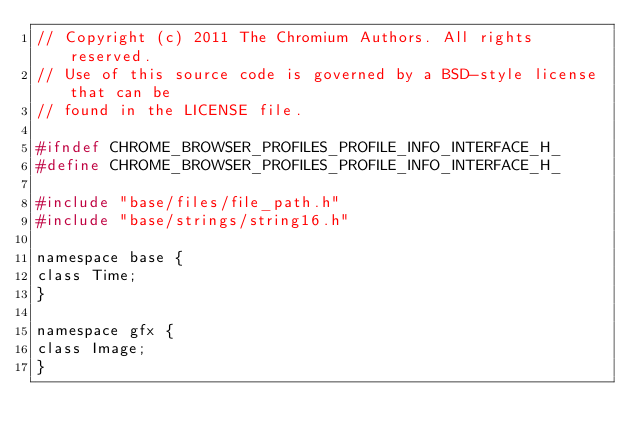Convert code to text. <code><loc_0><loc_0><loc_500><loc_500><_C_>// Copyright (c) 2011 The Chromium Authors. All rights reserved.
// Use of this source code is governed by a BSD-style license that can be
// found in the LICENSE file.

#ifndef CHROME_BROWSER_PROFILES_PROFILE_INFO_INTERFACE_H_
#define CHROME_BROWSER_PROFILES_PROFILE_INFO_INTERFACE_H_

#include "base/files/file_path.h"
#include "base/strings/string16.h"

namespace base {
class Time;
}

namespace gfx {
class Image;
}
</code> 